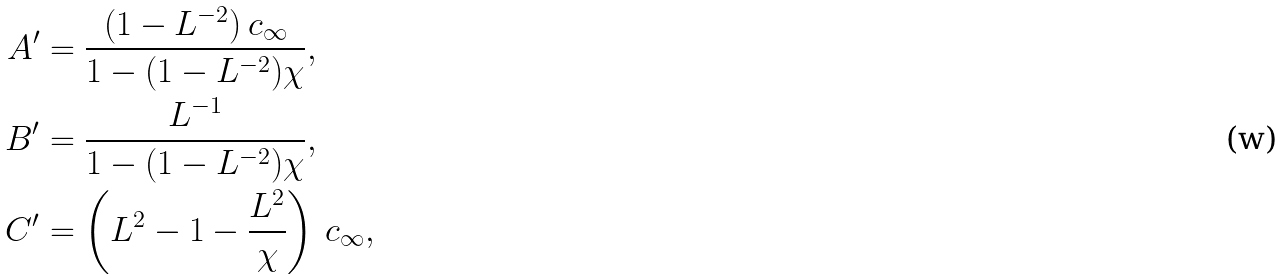<formula> <loc_0><loc_0><loc_500><loc_500>A ^ { \prime } & = \frac { ( 1 - L ^ { - 2 } ) \, c _ { \infty } } { 1 - ( 1 - L ^ { - 2 } ) \chi } , \\ B ^ { \prime } & = \frac { L ^ { - 1 } } { 1 - ( 1 - L ^ { - 2 } ) \chi } , \\ C ^ { \prime } & = \left ( L ^ { 2 } - 1 - \frac { L ^ { 2 } } { \chi } \right ) \, c _ { \infty } ,</formula> 